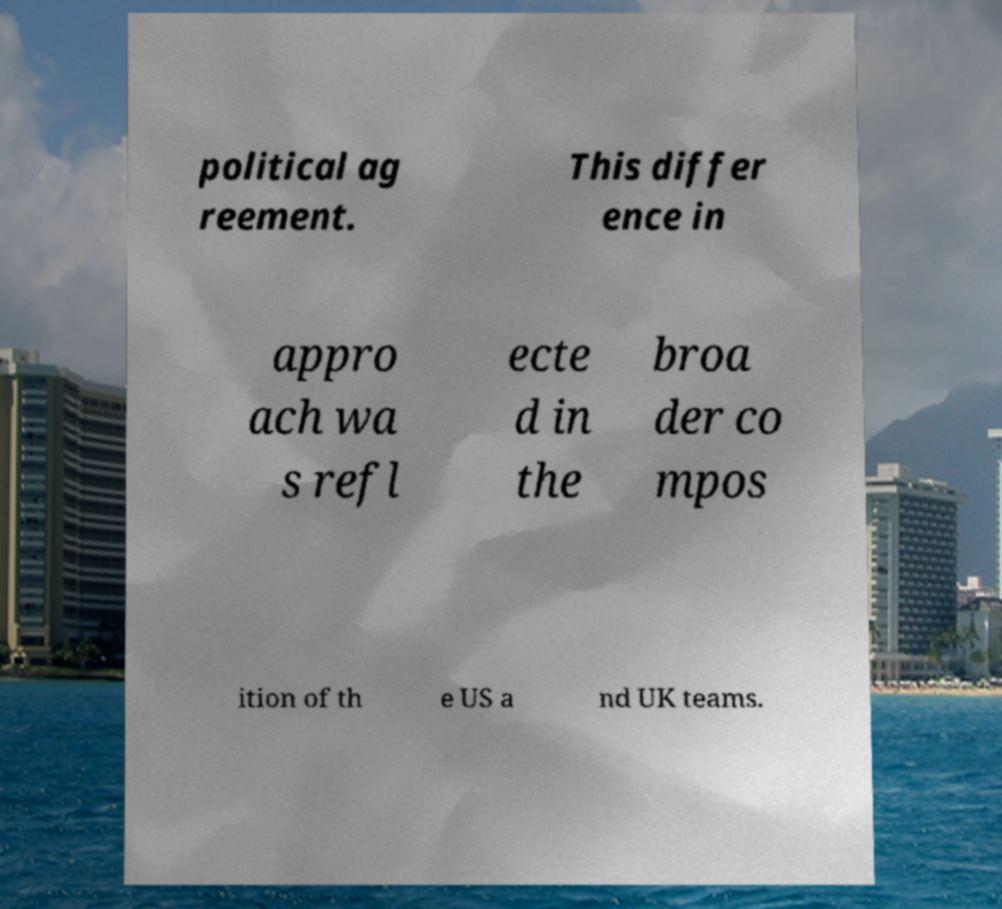Could you assist in decoding the text presented in this image and type it out clearly? political ag reement. This differ ence in appro ach wa s refl ecte d in the broa der co mpos ition of th e US a nd UK teams. 